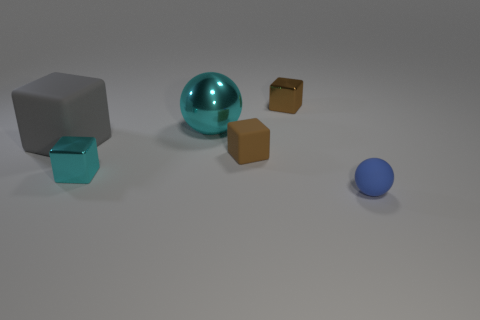Subtract all gray blocks. How many blocks are left? 3 Add 3 big brown matte blocks. How many objects exist? 9 Subtract all purple cylinders. How many brown blocks are left? 2 Subtract all blue balls. How many balls are left? 1 Subtract all spheres. How many objects are left? 4 Subtract 1 spheres. How many spheres are left? 1 Add 4 brown blocks. How many brown blocks exist? 6 Subtract 2 brown blocks. How many objects are left? 4 Subtract all gray cubes. Subtract all brown cylinders. How many cubes are left? 3 Subtract all big yellow metallic blocks. Subtract all brown matte objects. How many objects are left? 5 